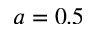<formula> <loc_0><loc_0><loc_500><loc_500>a = 0 . 5</formula> 